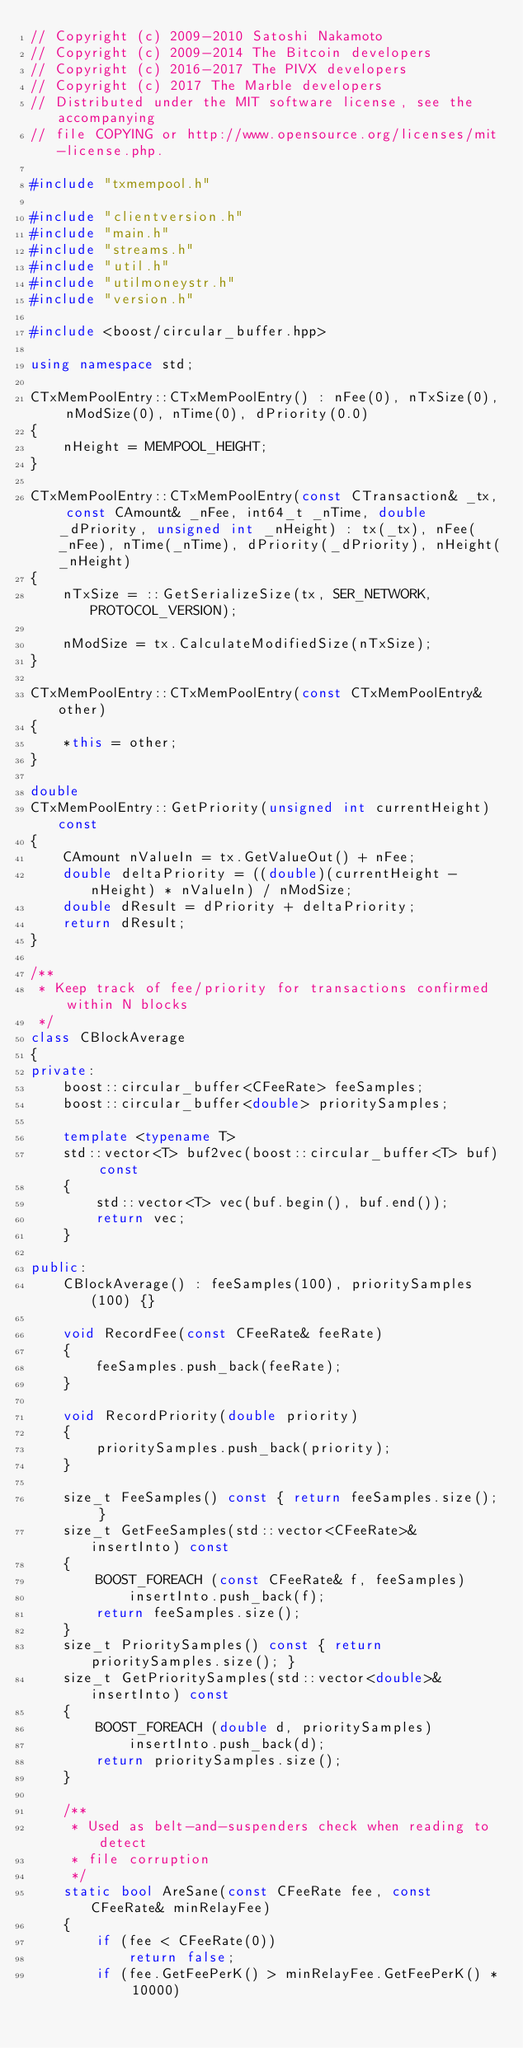<code> <loc_0><loc_0><loc_500><loc_500><_C++_>// Copyright (c) 2009-2010 Satoshi Nakamoto
// Copyright (c) 2009-2014 The Bitcoin developers
// Copyright (c) 2016-2017 The PIVX developers
// Copyright (c) 2017 The Marble developers
// Distributed under the MIT software license, see the accompanying
// file COPYING or http://www.opensource.org/licenses/mit-license.php.

#include "txmempool.h"

#include "clientversion.h"
#include "main.h"
#include "streams.h"
#include "util.h"
#include "utilmoneystr.h"
#include "version.h"

#include <boost/circular_buffer.hpp>

using namespace std;

CTxMemPoolEntry::CTxMemPoolEntry() : nFee(0), nTxSize(0), nModSize(0), nTime(0), dPriority(0.0)
{
    nHeight = MEMPOOL_HEIGHT;
}

CTxMemPoolEntry::CTxMemPoolEntry(const CTransaction& _tx, const CAmount& _nFee, int64_t _nTime, double _dPriority, unsigned int _nHeight) : tx(_tx), nFee(_nFee), nTime(_nTime), dPriority(_dPriority), nHeight(_nHeight)
{
    nTxSize = ::GetSerializeSize(tx, SER_NETWORK, PROTOCOL_VERSION);

    nModSize = tx.CalculateModifiedSize(nTxSize);
}

CTxMemPoolEntry::CTxMemPoolEntry(const CTxMemPoolEntry& other)
{
    *this = other;
}

double
CTxMemPoolEntry::GetPriority(unsigned int currentHeight) const
{
    CAmount nValueIn = tx.GetValueOut() + nFee;
    double deltaPriority = ((double)(currentHeight - nHeight) * nValueIn) / nModSize;
    double dResult = dPriority + deltaPriority;
    return dResult;
}

/**
 * Keep track of fee/priority for transactions confirmed within N blocks
 */
class CBlockAverage
{
private:
    boost::circular_buffer<CFeeRate> feeSamples;
    boost::circular_buffer<double> prioritySamples;

    template <typename T>
    std::vector<T> buf2vec(boost::circular_buffer<T> buf) const
    {
        std::vector<T> vec(buf.begin(), buf.end());
        return vec;
    }

public:
    CBlockAverage() : feeSamples(100), prioritySamples(100) {}

    void RecordFee(const CFeeRate& feeRate)
    {
        feeSamples.push_back(feeRate);
    }

    void RecordPriority(double priority)
    {
        prioritySamples.push_back(priority);
    }

    size_t FeeSamples() const { return feeSamples.size(); }
    size_t GetFeeSamples(std::vector<CFeeRate>& insertInto) const
    {
        BOOST_FOREACH (const CFeeRate& f, feeSamples)
            insertInto.push_back(f);
        return feeSamples.size();
    }
    size_t PrioritySamples() const { return prioritySamples.size(); }
    size_t GetPrioritySamples(std::vector<double>& insertInto) const
    {
        BOOST_FOREACH (double d, prioritySamples)
            insertInto.push_back(d);
        return prioritySamples.size();
    }

    /**
     * Used as belt-and-suspenders check when reading to detect
     * file corruption
     */
    static bool AreSane(const CFeeRate fee, const CFeeRate& minRelayFee)
    {
        if (fee < CFeeRate(0))
            return false;
        if (fee.GetFeePerK() > minRelayFee.GetFeePerK() * 10000)</code> 